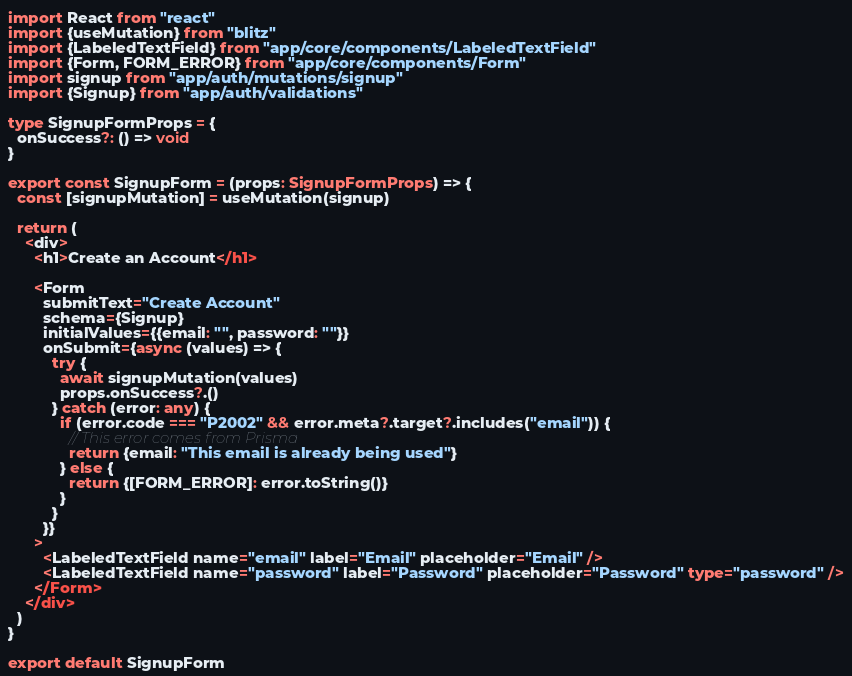<code> <loc_0><loc_0><loc_500><loc_500><_TypeScript_>import React from "react"
import {useMutation} from "blitz"
import {LabeledTextField} from "app/core/components/LabeledTextField"
import {Form, FORM_ERROR} from "app/core/components/Form"
import signup from "app/auth/mutations/signup"
import {Signup} from "app/auth/validations"

type SignupFormProps = {
  onSuccess?: () => void
}

export const SignupForm = (props: SignupFormProps) => {
  const [signupMutation] = useMutation(signup)

  return (
    <div>
      <h1>Create an Account</h1>

      <Form
        submitText="Create Account"
        schema={Signup}
        initialValues={{email: "", password: ""}}
        onSubmit={async (values) => {
          try {
            await signupMutation(values)
            props.onSuccess?.()
          } catch (error: any) {
            if (error.code === "P2002" && error.meta?.target?.includes("email")) {
              // This error comes from Prisma
              return {email: "This email is already being used"}
            } else {
              return {[FORM_ERROR]: error.toString()}
            }
          }
        }}
      >
        <LabeledTextField name="email" label="Email" placeholder="Email" />
        <LabeledTextField name="password" label="Password" placeholder="Password" type="password" />
      </Form>
    </div>
  )
}

export default SignupForm
</code> 